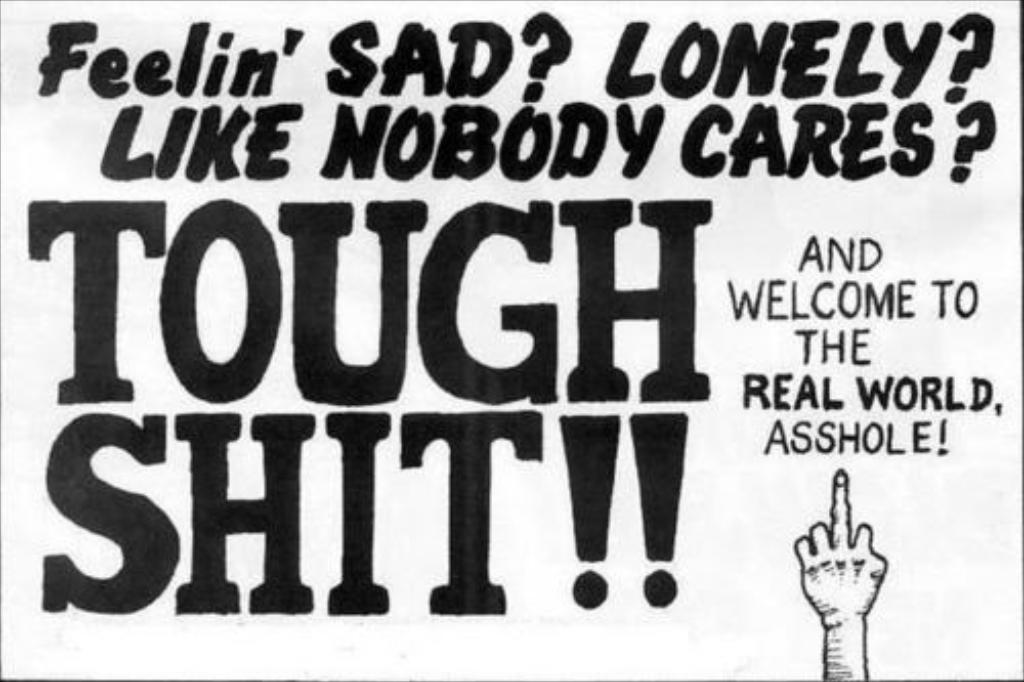<image>
Describe the image concisely. Poster in black and white that says "Tough Shit" on the bottom. 